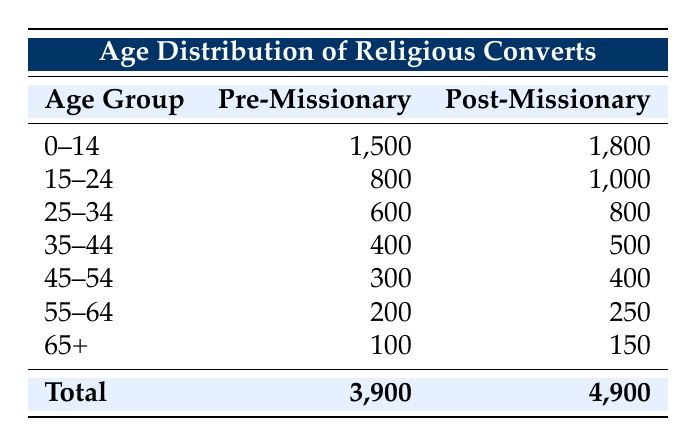What is the total number of religious converts pre-missionary intervention? The table shows that the total for pre-missionary intervention is listed in the last row under the "Pre-Missionary" column, which states 3,900.
Answer: 3,900 How many individuals in the age group 25-34 converted post-missionary intervention? In the table, for the age group 25-34 under the "Post-Missionary" column, the value is 800.
Answer: 800 What is the difference in the number of converts in the age group 15-24 before and after missionary intervention? For the age group 15-24, pre-missionary intervention shows 800 converts and post-missionary intervention shows 1,000 converts. The difference is calculated as 1,000 - 800 = 200.
Answer: 200 Is the number of converts aged 65 and above greater post-missionary intervention than pre-missionary intervention? The table indicates that for those aged 65 and above, there were 100 pre-missionary and 150 post-missionary. Since 150 is greater than 100, the answer is yes.
Answer: Yes What is the combined total number of converts aged 0-14 and 15-24 before missionary intervention? To find the total, add the number of converts aged 0-14 (1,500) and 15-24 (800) before missionary intervention. Thus, 1,500 + 800 = 2,300.
Answer: 2,300 What percentage of the total converts post-missionary intervention fall in the age group 55-64? Post-missionary, there are 250 converts in the 55-64 age group and a total of 4,900. The percentage is calculated as (250 / 4,900) * 100, which is approximately 5.10%.
Answer: 5.10% Was there an overall increase in the total number of religious converts from pre-missionary to post-missionary intervention? Comparing the totals, pre-missionary intervention had 3,900 converts and post-missionary intervention had 4,900 converts. Since 4,900 is greater than 3,900, the answer is yes.
Answer: Yes What is the average number of converts per age group pre-missionary intervention? There are seven age groups listed in the pre-missionary intervention section. Summing the values (1,500 + 800 + 600 + 400 + 300 + 200 + 100 = 3,900) and dividing by 7 gives an average of 3,900 / 7, which is approximately 557.14.
Answer: 557.14 How many more converts were there in the age group 35-44 after missionary intervention compared to before? The table shows that there were 400 converts in the age group 35-44 pre-missionary and 500 post-missionary. The increase is calculated as 500 - 400 = 100.
Answer: 100 